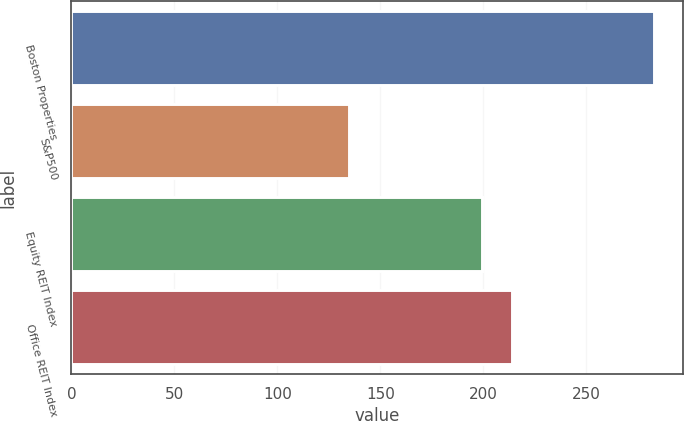Convert chart. <chart><loc_0><loc_0><loc_500><loc_500><bar_chart><fcel>Boston Properties<fcel>S&P500<fcel>Equity REIT Index<fcel>Office REIT Index<nl><fcel>282.59<fcel>134.69<fcel>199.33<fcel>214.12<nl></chart> 